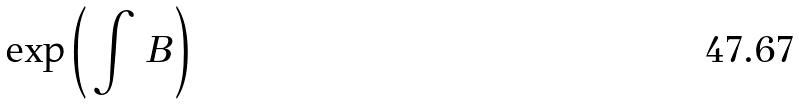Convert formula to latex. <formula><loc_0><loc_0><loc_500><loc_500>\exp \left ( \, \int \, B \, \right )</formula> 